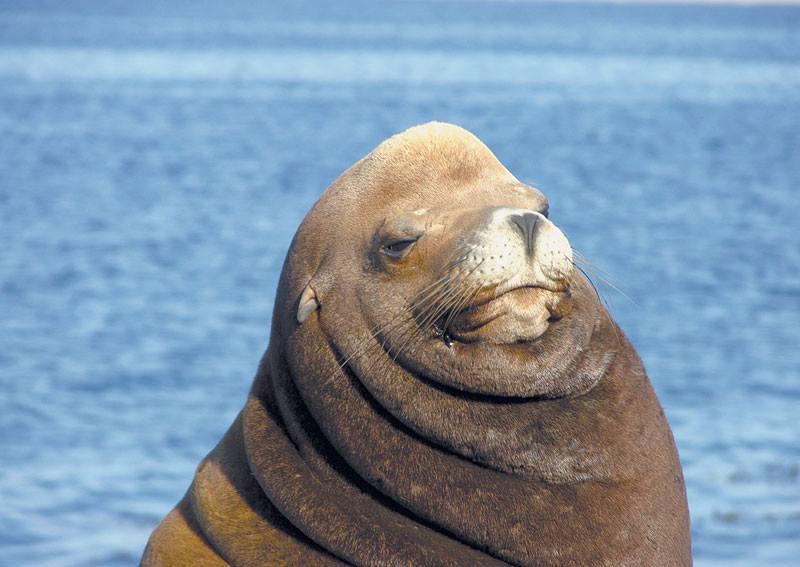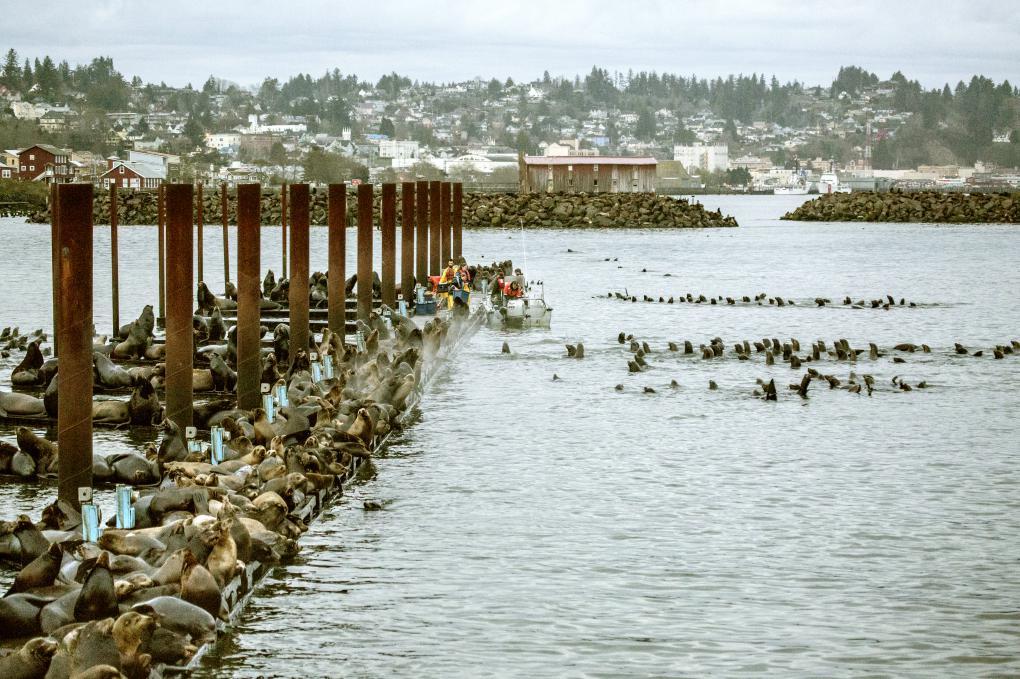The first image is the image on the left, the second image is the image on the right. Examine the images to the left and right. Is the description "Some of the sea lions have markings made by humans on them." accurate? Answer yes or no. No. The first image is the image on the left, the second image is the image on the right. Evaluate the accuracy of this statement regarding the images: "An image contains no more than one seal.". Is it true? Answer yes or no. Yes. 